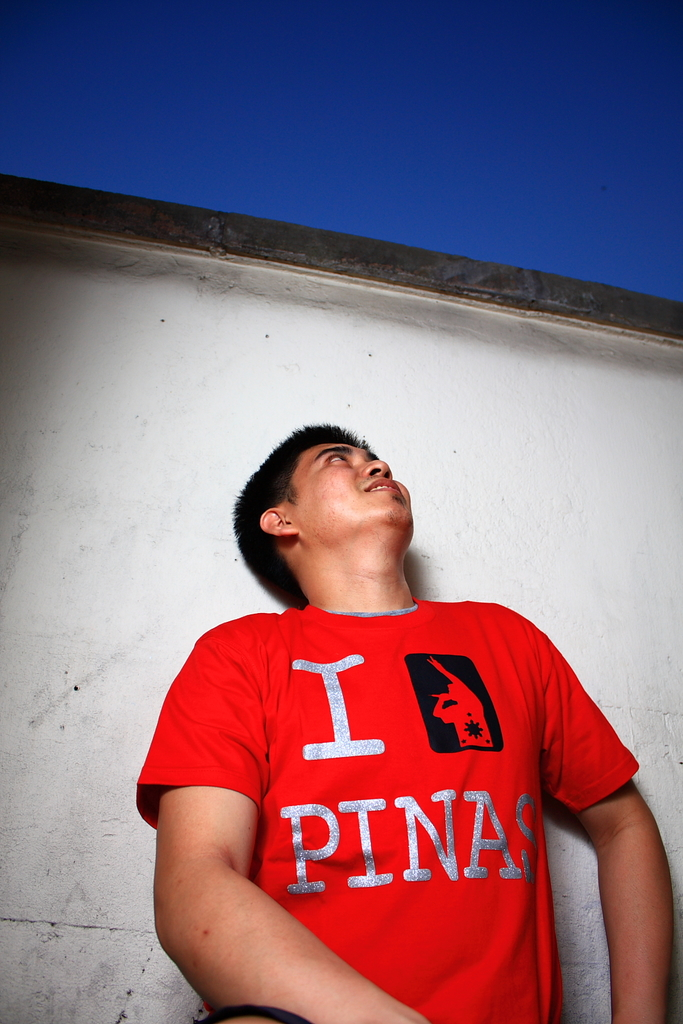Can you describe the setting and how it contributes to the photo's mood? The sparse white wall and the clear blue sky seen at the very edge frame the subject in a stark, uncluttered way that focuses attention completely on his expression and the vibrant red of his shirt, conveying a sense of openness and simplicity in the setting. 